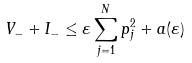Convert formula to latex. <formula><loc_0><loc_0><loc_500><loc_500>V _ { - } + I _ { - } \leq \varepsilon \sum _ { j = 1 } ^ { N } p _ { j } ^ { 2 } + a ( \varepsilon )</formula> 